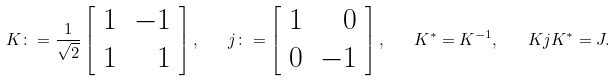Convert formula to latex. <formula><loc_0><loc_0><loc_500><loc_500>K \colon = \frac { 1 } { \sqrt { 2 } } \left [ \begin{array} { l r } 1 & - 1 \\ 1 & 1 \end{array} \right ] , \quad j \colon = \left [ \begin{array} { l r } 1 & 0 \\ 0 & - 1 \end{array} \right ] , \quad K ^ { * } = K ^ { - 1 } , \quad K j K ^ { * } = J .</formula> 